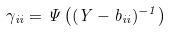<formula> <loc_0><loc_0><loc_500><loc_500>\gamma _ { i i } = \Psi \left ( ( Y - b _ { i i } ) ^ { - 1 } \right )</formula> 